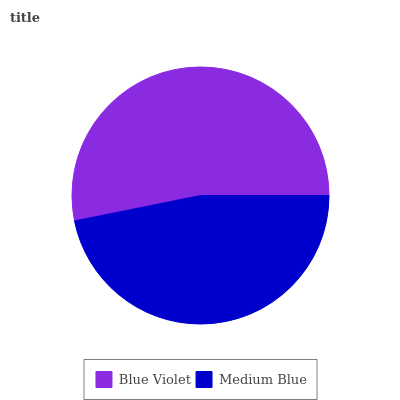Is Medium Blue the minimum?
Answer yes or no. Yes. Is Blue Violet the maximum?
Answer yes or no. Yes. Is Medium Blue the maximum?
Answer yes or no. No. Is Blue Violet greater than Medium Blue?
Answer yes or no. Yes. Is Medium Blue less than Blue Violet?
Answer yes or no. Yes. Is Medium Blue greater than Blue Violet?
Answer yes or no. No. Is Blue Violet less than Medium Blue?
Answer yes or no. No. Is Blue Violet the high median?
Answer yes or no. Yes. Is Medium Blue the low median?
Answer yes or no. Yes. Is Medium Blue the high median?
Answer yes or no. No. Is Blue Violet the low median?
Answer yes or no. No. 